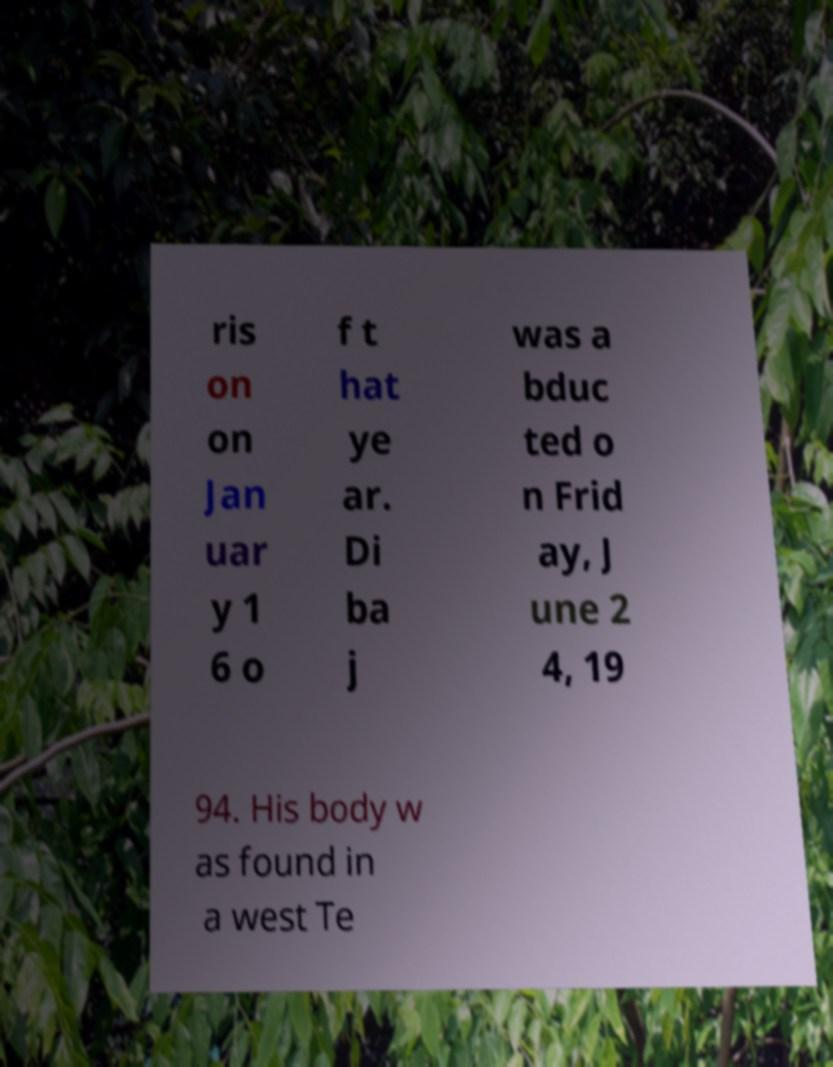For documentation purposes, I need the text within this image transcribed. Could you provide that? ris on on Jan uar y 1 6 o f t hat ye ar. Di ba j was a bduc ted o n Frid ay, J une 2 4, 19 94. His body w as found in a west Te 